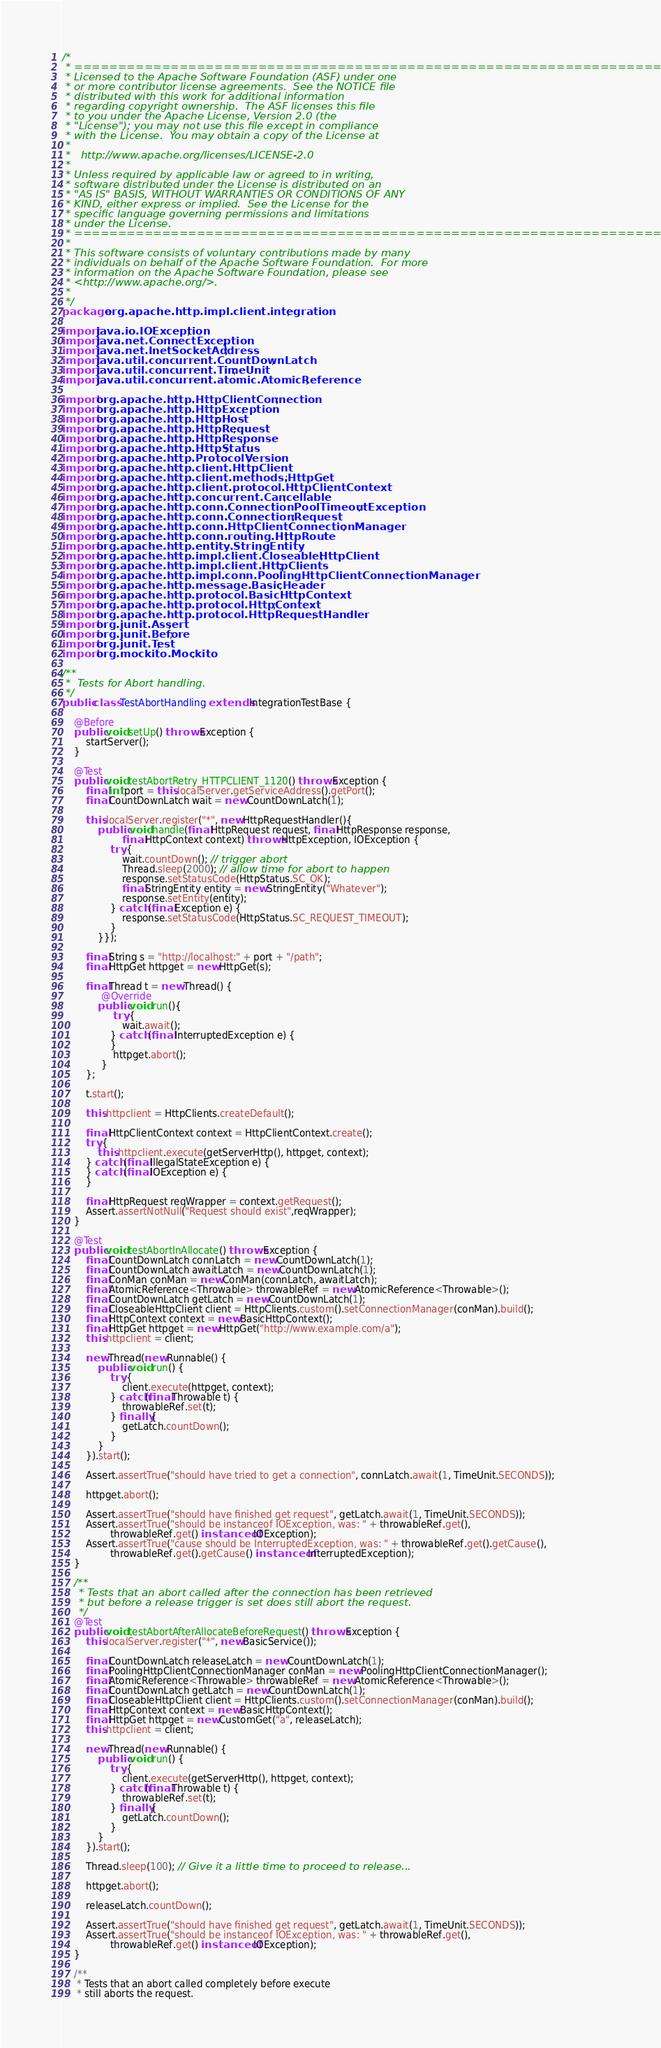Convert code to text. <code><loc_0><loc_0><loc_500><loc_500><_Java_>/*
 * ====================================================================
 * Licensed to the Apache Software Foundation (ASF) under one
 * or more contributor license agreements.  See the NOTICE file
 * distributed with this work for additional information
 * regarding copyright ownership.  The ASF licenses this file
 * to you under the Apache License, Version 2.0 (the
 * "License"); you may not use this file except in compliance
 * with the License.  You may obtain a copy of the License at
 *
 *   http://www.apache.org/licenses/LICENSE-2.0
 *
 * Unless required by applicable law or agreed to in writing,
 * software distributed under the License is distributed on an
 * "AS IS" BASIS, WITHOUT WARRANTIES OR CONDITIONS OF ANY
 * KIND, either express or implied.  See the License for the
 * specific language governing permissions and limitations
 * under the License.
 * ====================================================================
 *
 * This software consists of voluntary contributions made by many
 * individuals on behalf of the Apache Software Foundation.  For more
 * information on the Apache Software Foundation, please see
 * <http://www.apache.org/>.
 *
 */
package org.apache.http.impl.client.integration;

import java.io.IOException;
import java.net.ConnectException;
import java.net.InetSocketAddress;
import java.util.concurrent.CountDownLatch;
import java.util.concurrent.TimeUnit;
import java.util.concurrent.atomic.AtomicReference;

import org.apache.http.HttpClientConnection;
import org.apache.http.HttpException;
import org.apache.http.HttpHost;
import org.apache.http.HttpRequest;
import org.apache.http.HttpResponse;
import org.apache.http.HttpStatus;
import org.apache.http.ProtocolVersion;
import org.apache.http.client.HttpClient;
import org.apache.http.client.methods.HttpGet;
import org.apache.http.client.protocol.HttpClientContext;
import org.apache.http.concurrent.Cancellable;
import org.apache.http.conn.ConnectionPoolTimeoutException;
import org.apache.http.conn.ConnectionRequest;
import org.apache.http.conn.HttpClientConnectionManager;
import org.apache.http.conn.routing.HttpRoute;
import org.apache.http.entity.StringEntity;
import org.apache.http.impl.client.CloseableHttpClient;
import org.apache.http.impl.client.HttpClients;
import org.apache.http.impl.conn.PoolingHttpClientConnectionManager;
import org.apache.http.message.BasicHeader;
import org.apache.http.protocol.BasicHttpContext;
import org.apache.http.protocol.HttpContext;
import org.apache.http.protocol.HttpRequestHandler;
import org.junit.Assert;
import org.junit.Before;
import org.junit.Test;
import org.mockito.Mockito;

/**
 *  Tests for Abort handling.
 */
public class TestAbortHandling extends IntegrationTestBase {

    @Before
    public void setUp() throws Exception {
        startServer();
    }

    @Test
    public void testAbortRetry_HTTPCLIENT_1120() throws Exception {
        final int port = this.localServer.getServiceAddress().getPort();
        final CountDownLatch wait = new CountDownLatch(1);

        this.localServer.register("*", new HttpRequestHandler(){
            public void handle(final HttpRequest request, final HttpResponse response,
                    final HttpContext context) throws HttpException, IOException {
                try {
                    wait.countDown(); // trigger abort
                    Thread.sleep(2000); // allow time for abort to happen
                    response.setStatusCode(HttpStatus.SC_OK);
                    final StringEntity entity = new StringEntity("Whatever");
                    response.setEntity(entity);
                } catch (final Exception e) {
                    response.setStatusCode(HttpStatus.SC_REQUEST_TIMEOUT);
                }
            }});

        final String s = "http://localhost:" + port + "/path";
        final HttpGet httpget = new HttpGet(s);

        final Thread t = new Thread() {
             @Override
            public void run(){
                 try {
                    wait.await();
                } catch (final InterruptedException e) {
                }
                 httpget.abort();
             }
        };

        t.start();

        this.httpclient = HttpClients.createDefault();

        final HttpClientContext context = HttpClientContext.create();
        try {
            this.httpclient.execute(getServerHttp(), httpget, context);
        } catch (final IllegalStateException e) {
        } catch (final IOException e) {
        }

        final HttpRequest reqWrapper = context.getRequest();
        Assert.assertNotNull("Request should exist",reqWrapper);
    }

    @Test
    public void testAbortInAllocate() throws Exception {
        final CountDownLatch connLatch = new CountDownLatch(1);
        final CountDownLatch awaitLatch = new CountDownLatch(1);
        final ConMan conMan = new ConMan(connLatch, awaitLatch);
        final AtomicReference<Throwable> throwableRef = new AtomicReference<Throwable>();
        final CountDownLatch getLatch = new CountDownLatch(1);
        final CloseableHttpClient client = HttpClients.custom().setConnectionManager(conMan).build();
        final HttpContext context = new BasicHttpContext();
        final HttpGet httpget = new HttpGet("http://www.example.com/a");
        this.httpclient = client;

        new Thread(new Runnable() {
            public void run() {
                try {
                    client.execute(httpget, context);
                } catch(final Throwable t) {
                    throwableRef.set(t);
                } finally {
                    getLatch.countDown();
                }
            }
        }).start();

        Assert.assertTrue("should have tried to get a connection", connLatch.await(1, TimeUnit.SECONDS));

        httpget.abort();

        Assert.assertTrue("should have finished get request", getLatch.await(1, TimeUnit.SECONDS));
        Assert.assertTrue("should be instanceof IOException, was: " + throwableRef.get(),
                throwableRef.get() instanceof IOException);
        Assert.assertTrue("cause should be InterruptedException, was: " + throwableRef.get().getCause(),
                throwableRef.get().getCause() instanceof InterruptedException);
    }

    /**
     * Tests that an abort called after the connection has been retrieved
     * but before a release trigger is set does still abort the request.
     */
    @Test
    public void testAbortAfterAllocateBeforeRequest() throws Exception {
        this.localServer.register("*", new BasicService());

        final CountDownLatch releaseLatch = new CountDownLatch(1);
        final PoolingHttpClientConnectionManager conMan = new PoolingHttpClientConnectionManager();
        final AtomicReference<Throwable> throwableRef = new AtomicReference<Throwable>();
        final CountDownLatch getLatch = new CountDownLatch(1);
        final CloseableHttpClient client = HttpClients.custom().setConnectionManager(conMan).build();
        final HttpContext context = new BasicHttpContext();
        final HttpGet httpget = new CustomGet("a", releaseLatch);
        this.httpclient = client;

        new Thread(new Runnable() {
            public void run() {
                try {
                    client.execute(getServerHttp(), httpget, context);
                } catch(final Throwable t) {
                    throwableRef.set(t);
                } finally {
                    getLatch.countDown();
                }
            }
        }).start();

        Thread.sleep(100); // Give it a little time to proceed to release...

        httpget.abort();

        releaseLatch.countDown();

        Assert.assertTrue("should have finished get request", getLatch.await(1, TimeUnit.SECONDS));
        Assert.assertTrue("should be instanceof IOException, was: " + throwableRef.get(),
                throwableRef.get() instanceof IOException);
    }

    /**
     * Tests that an abort called completely before execute
     * still aborts the request.</code> 